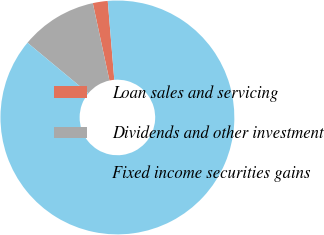<chart> <loc_0><loc_0><loc_500><loc_500><pie_chart><fcel>Loan sales and servicing<fcel>Dividends and other investment<fcel>Fixed income securities gains<nl><fcel>2.06%<fcel>10.59%<fcel>87.36%<nl></chart> 